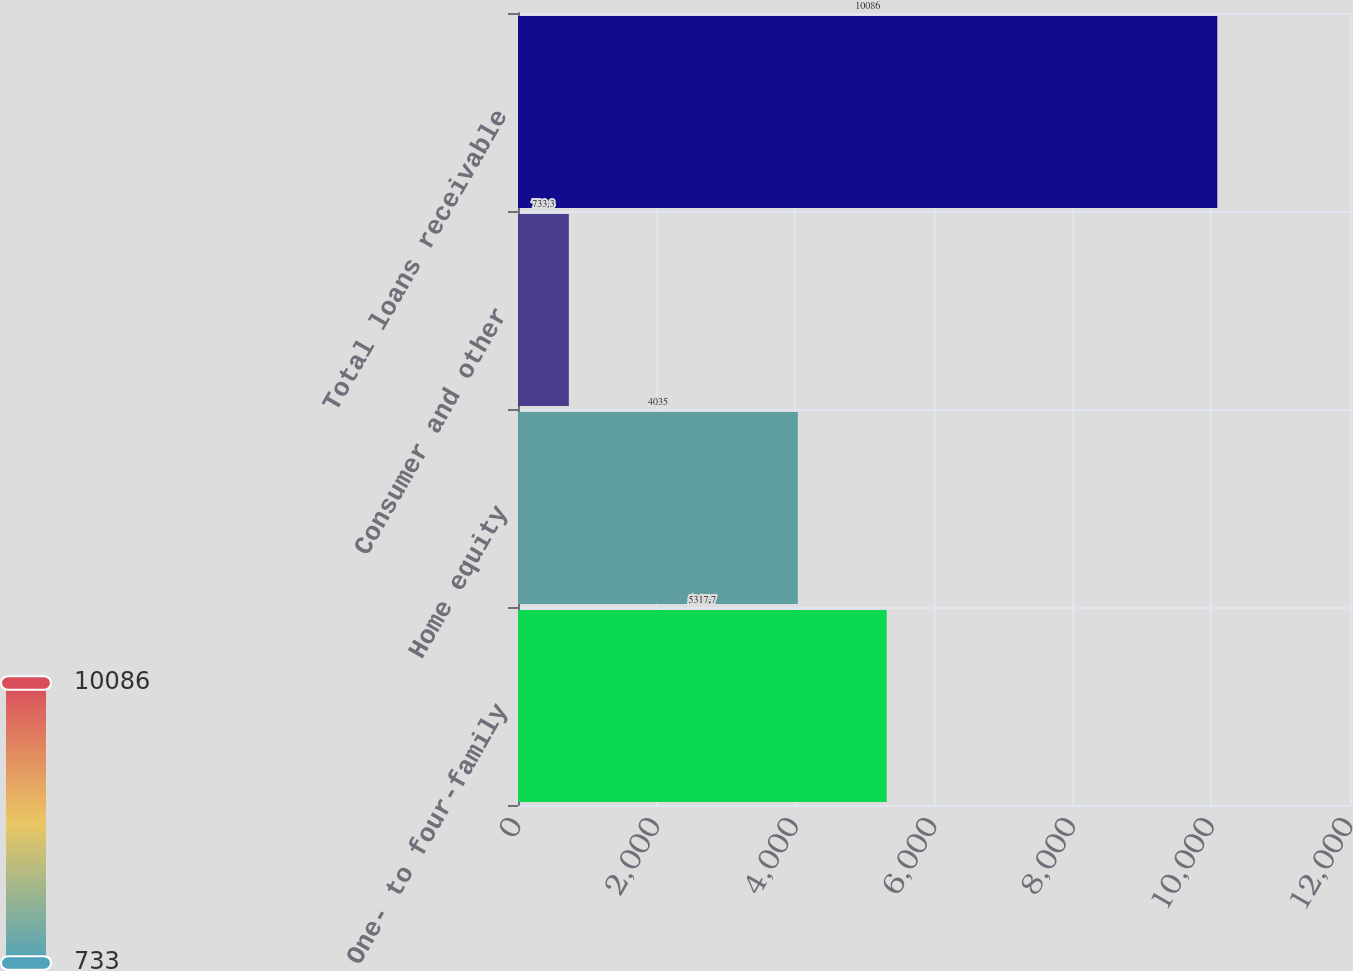<chart> <loc_0><loc_0><loc_500><loc_500><bar_chart><fcel>One- to four-family<fcel>Home equity<fcel>Consumer and other<fcel>Total loans receivable<nl><fcel>5317.7<fcel>4035<fcel>733.3<fcel>10086<nl></chart> 